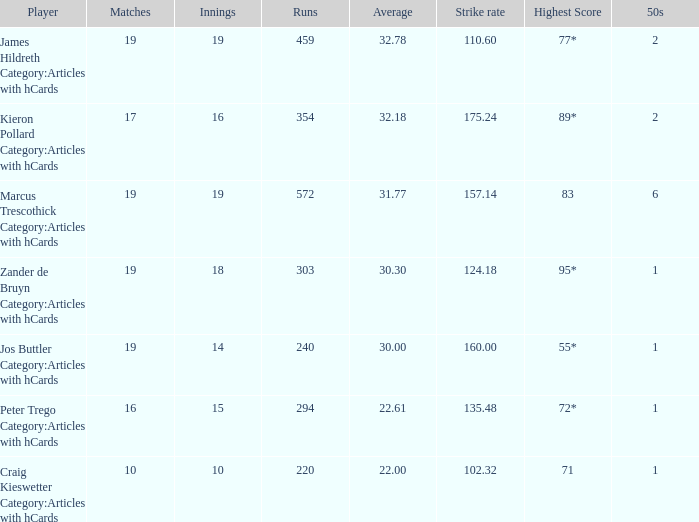78? 110.6. 